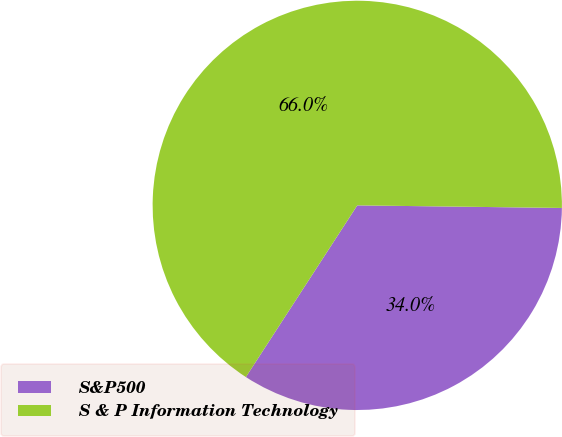Convert chart to OTSL. <chart><loc_0><loc_0><loc_500><loc_500><pie_chart><fcel>S&P500<fcel>S & P Information Technology<nl><fcel>33.96%<fcel>66.04%<nl></chart> 